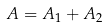Convert formula to latex. <formula><loc_0><loc_0><loc_500><loc_500>A = A _ { 1 } + A _ { 2 }</formula> 